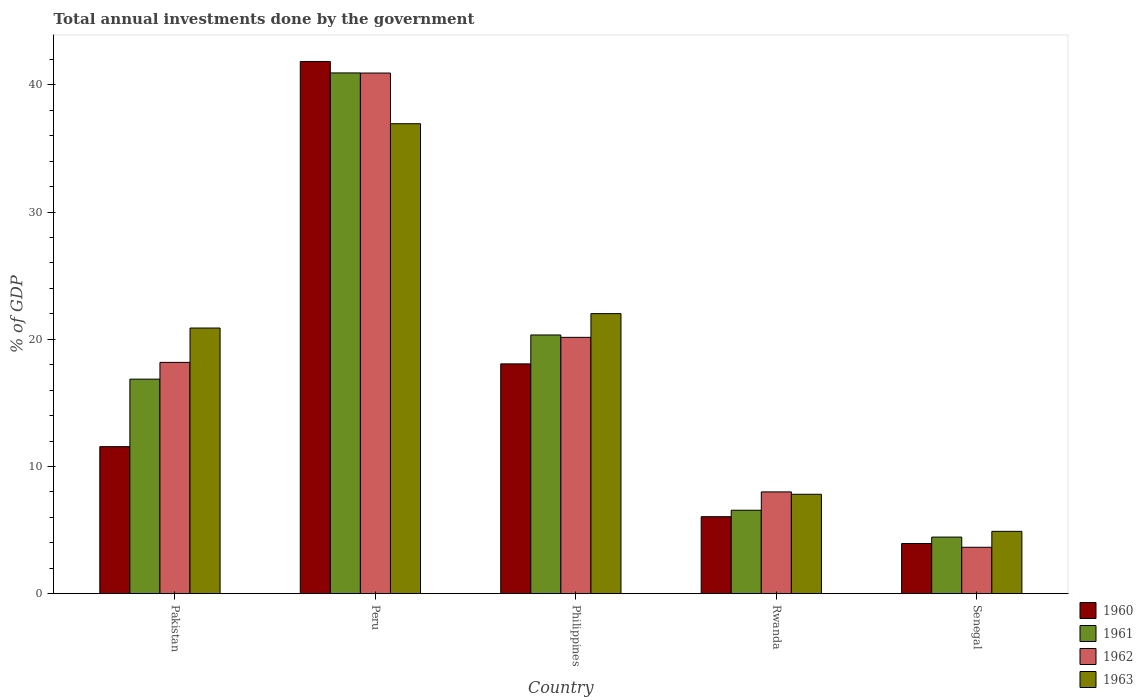How many different coloured bars are there?
Make the answer very short. 4. How many groups of bars are there?
Your response must be concise. 5. Are the number of bars per tick equal to the number of legend labels?
Offer a terse response. Yes. How many bars are there on the 1st tick from the left?
Keep it short and to the point. 4. What is the label of the 1st group of bars from the left?
Your answer should be compact. Pakistan. What is the total annual investments done by the government in 1961 in Senegal?
Make the answer very short. 4.45. Across all countries, what is the maximum total annual investments done by the government in 1960?
Your response must be concise. 41.84. Across all countries, what is the minimum total annual investments done by the government in 1962?
Ensure brevity in your answer.  3.65. In which country was the total annual investments done by the government in 1960 minimum?
Keep it short and to the point. Senegal. What is the total total annual investments done by the government in 1962 in the graph?
Offer a terse response. 90.91. What is the difference between the total annual investments done by the government in 1962 in Peru and that in Philippines?
Ensure brevity in your answer.  20.78. What is the difference between the total annual investments done by the government in 1960 in Philippines and the total annual investments done by the government in 1962 in Rwanda?
Offer a terse response. 10.06. What is the average total annual investments done by the government in 1961 per country?
Make the answer very short. 17.83. What is the difference between the total annual investments done by the government of/in 1961 and total annual investments done by the government of/in 1960 in Philippines?
Give a very brief answer. 2.27. In how many countries, is the total annual investments done by the government in 1963 greater than 40 %?
Provide a short and direct response. 0. What is the ratio of the total annual investments done by the government in 1960 in Peru to that in Rwanda?
Provide a succinct answer. 6.91. What is the difference between the highest and the second highest total annual investments done by the government in 1960?
Keep it short and to the point. 23.77. What is the difference between the highest and the lowest total annual investments done by the government in 1963?
Ensure brevity in your answer.  32.04. What does the 4th bar from the right in Rwanda represents?
Your response must be concise. 1960. How many bars are there?
Your response must be concise. 20. What is the difference between two consecutive major ticks on the Y-axis?
Provide a succinct answer. 10. Are the values on the major ticks of Y-axis written in scientific E-notation?
Your answer should be very brief. No. Does the graph contain grids?
Provide a succinct answer. No. What is the title of the graph?
Offer a terse response. Total annual investments done by the government. What is the label or title of the X-axis?
Give a very brief answer. Country. What is the label or title of the Y-axis?
Your response must be concise. % of GDP. What is the % of GDP of 1960 in Pakistan?
Give a very brief answer. 11.56. What is the % of GDP in 1961 in Pakistan?
Ensure brevity in your answer.  16.86. What is the % of GDP in 1962 in Pakistan?
Give a very brief answer. 18.18. What is the % of GDP of 1963 in Pakistan?
Provide a succinct answer. 20.88. What is the % of GDP of 1960 in Peru?
Give a very brief answer. 41.84. What is the % of GDP of 1961 in Peru?
Provide a succinct answer. 40.94. What is the % of GDP in 1962 in Peru?
Provide a succinct answer. 40.93. What is the % of GDP of 1963 in Peru?
Ensure brevity in your answer.  36.94. What is the % of GDP of 1960 in Philippines?
Ensure brevity in your answer.  18.06. What is the % of GDP of 1961 in Philippines?
Give a very brief answer. 20.34. What is the % of GDP of 1962 in Philippines?
Ensure brevity in your answer.  20.15. What is the % of GDP of 1963 in Philippines?
Give a very brief answer. 22.02. What is the % of GDP in 1960 in Rwanda?
Your response must be concise. 6.05. What is the % of GDP of 1961 in Rwanda?
Provide a short and direct response. 6.56. What is the % of GDP of 1962 in Rwanda?
Give a very brief answer. 8. What is the % of GDP of 1963 in Rwanda?
Give a very brief answer. 7.81. What is the % of GDP in 1960 in Senegal?
Your answer should be compact. 3.94. What is the % of GDP of 1961 in Senegal?
Offer a very short reply. 4.45. What is the % of GDP of 1962 in Senegal?
Your answer should be compact. 3.65. What is the % of GDP of 1963 in Senegal?
Your answer should be compact. 4.9. Across all countries, what is the maximum % of GDP of 1960?
Keep it short and to the point. 41.84. Across all countries, what is the maximum % of GDP in 1961?
Your response must be concise. 40.94. Across all countries, what is the maximum % of GDP of 1962?
Give a very brief answer. 40.93. Across all countries, what is the maximum % of GDP in 1963?
Keep it short and to the point. 36.94. Across all countries, what is the minimum % of GDP in 1960?
Ensure brevity in your answer.  3.94. Across all countries, what is the minimum % of GDP of 1961?
Provide a succinct answer. 4.45. Across all countries, what is the minimum % of GDP of 1962?
Your answer should be compact. 3.65. Across all countries, what is the minimum % of GDP of 1963?
Your answer should be very brief. 4.9. What is the total % of GDP of 1960 in the graph?
Keep it short and to the point. 81.45. What is the total % of GDP in 1961 in the graph?
Provide a short and direct response. 89.14. What is the total % of GDP in 1962 in the graph?
Provide a succinct answer. 90.91. What is the total % of GDP of 1963 in the graph?
Offer a terse response. 92.55. What is the difference between the % of GDP in 1960 in Pakistan and that in Peru?
Provide a succinct answer. -30.28. What is the difference between the % of GDP of 1961 in Pakistan and that in Peru?
Your response must be concise. -24.07. What is the difference between the % of GDP in 1962 in Pakistan and that in Peru?
Your answer should be compact. -22.75. What is the difference between the % of GDP in 1963 in Pakistan and that in Peru?
Your answer should be very brief. -16.06. What is the difference between the % of GDP in 1960 in Pakistan and that in Philippines?
Make the answer very short. -6.51. What is the difference between the % of GDP in 1961 in Pakistan and that in Philippines?
Give a very brief answer. -3.47. What is the difference between the % of GDP in 1962 in Pakistan and that in Philippines?
Ensure brevity in your answer.  -1.97. What is the difference between the % of GDP in 1963 in Pakistan and that in Philippines?
Provide a short and direct response. -1.13. What is the difference between the % of GDP of 1960 in Pakistan and that in Rwanda?
Provide a succinct answer. 5.51. What is the difference between the % of GDP in 1961 in Pakistan and that in Rwanda?
Provide a short and direct response. 10.31. What is the difference between the % of GDP in 1962 in Pakistan and that in Rwanda?
Your response must be concise. 10.18. What is the difference between the % of GDP of 1963 in Pakistan and that in Rwanda?
Make the answer very short. 13.07. What is the difference between the % of GDP in 1960 in Pakistan and that in Senegal?
Provide a short and direct response. 7.62. What is the difference between the % of GDP in 1961 in Pakistan and that in Senegal?
Make the answer very short. 12.42. What is the difference between the % of GDP in 1962 in Pakistan and that in Senegal?
Your answer should be very brief. 14.53. What is the difference between the % of GDP of 1963 in Pakistan and that in Senegal?
Your answer should be compact. 15.98. What is the difference between the % of GDP of 1960 in Peru and that in Philippines?
Offer a very short reply. 23.77. What is the difference between the % of GDP in 1961 in Peru and that in Philippines?
Make the answer very short. 20.6. What is the difference between the % of GDP of 1962 in Peru and that in Philippines?
Ensure brevity in your answer.  20.78. What is the difference between the % of GDP in 1963 in Peru and that in Philippines?
Offer a terse response. 14.93. What is the difference between the % of GDP in 1960 in Peru and that in Rwanda?
Make the answer very short. 35.79. What is the difference between the % of GDP of 1961 in Peru and that in Rwanda?
Provide a short and direct response. 34.38. What is the difference between the % of GDP of 1962 in Peru and that in Rwanda?
Provide a succinct answer. 32.93. What is the difference between the % of GDP of 1963 in Peru and that in Rwanda?
Provide a short and direct response. 29.13. What is the difference between the % of GDP in 1960 in Peru and that in Senegal?
Keep it short and to the point. 37.9. What is the difference between the % of GDP of 1961 in Peru and that in Senegal?
Provide a succinct answer. 36.49. What is the difference between the % of GDP in 1962 in Peru and that in Senegal?
Provide a succinct answer. 37.28. What is the difference between the % of GDP of 1963 in Peru and that in Senegal?
Make the answer very short. 32.04. What is the difference between the % of GDP of 1960 in Philippines and that in Rwanda?
Offer a very short reply. 12.01. What is the difference between the % of GDP in 1961 in Philippines and that in Rwanda?
Keep it short and to the point. 13.78. What is the difference between the % of GDP of 1962 in Philippines and that in Rwanda?
Provide a short and direct response. 12.15. What is the difference between the % of GDP in 1963 in Philippines and that in Rwanda?
Your answer should be very brief. 14.2. What is the difference between the % of GDP in 1960 in Philippines and that in Senegal?
Offer a terse response. 14.12. What is the difference between the % of GDP in 1961 in Philippines and that in Senegal?
Your answer should be very brief. 15.89. What is the difference between the % of GDP of 1962 in Philippines and that in Senegal?
Keep it short and to the point. 16.5. What is the difference between the % of GDP of 1963 in Philippines and that in Senegal?
Your answer should be compact. 17.12. What is the difference between the % of GDP of 1960 in Rwanda and that in Senegal?
Make the answer very short. 2.11. What is the difference between the % of GDP in 1961 in Rwanda and that in Senegal?
Provide a short and direct response. 2.11. What is the difference between the % of GDP of 1962 in Rwanda and that in Senegal?
Make the answer very short. 4.35. What is the difference between the % of GDP of 1963 in Rwanda and that in Senegal?
Provide a short and direct response. 2.91. What is the difference between the % of GDP in 1960 in Pakistan and the % of GDP in 1961 in Peru?
Provide a succinct answer. -29.38. What is the difference between the % of GDP in 1960 in Pakistan and the % of GDP in 1962 in Peru?
Ensure brevity in your answer.  -29.37. What is the difference between the % of GDP of 1960 in Pakistan and the % of GDP of 1963 in Peru?
Offer a terse response. -25.39. What is the difference between the % of GDP of 1961 in Pakistan and the % of GDP of 1962 in Peru?
Give a very brief answer. -24.06. What is the difference between the % of GDP of 1961 in Pakistan and the % of GDP of 1963 in Peru?
Give a very brief answer. -20.08. What is the difference between the % of GDP in 1962 in Pakistan and the % of GDP in 1963 in Peru?
Ensure brevity in your answer.  -18.76. What is the difference between the % of GDP of 1960 in Pakistan and the % of GDP of 1961 in Philippines?
Provide a succinct answer. -8.78. What is the difference between the % of GDP in 1960 in Pakistan and the % of GDP in 1962 in Philippines?
Your response must be concise. -8.59. What is the difference between the % of GDP of 1960 in Pakistan and the % of GDP of 1963 in Philippines?
Your answer should be compact. -10.46. What is the difference between the % of GDP in 1961 in Pakistan and the % of GDP in 1962 in Philippines?
Make the answer very short. -3.29. What is the difference between the % of GDP in 1961 in Pakistan and the % of GDP in 1963 in Philippines?
Offer a very short reply. -5.15. What is the difference between the % of GDP of 1962 in Pakistan and the % of GDP of 1963 in Philippines?
Your answer should be very brief. -3.83. What is the difference between the % of GDP in 1960 in Pakistan and the % of GDP in 1961 in Rwanda?
Keep it short and to the point. 5. What is the difference between the % of GDP in 1960 in Pakistan and the % of GDP in 1962 in Rwanda?
Your answer should be compact. 3.56. What is the difference between the % of GDP of 1960 in Pakistan and the % of GDP of 1963 in Rwanda?
Keep it short and to the point. 3.74. What is the difference between the % of GDP in 1961 in Pakistan and the % of GDP in 1962 in Rwanda?
Your answer should be very brief. 8.86. What is the difference between the % of GDP in 1961 in Pakistan and the % of GDP in 1963 in Rwanda?
Your response must be concise. 9.05. What is the difference between the % of GDP in 1962 in Pakistan and the % of GDP in 1963 in Rwanda?
Make the answer very short. 10.37. What is the difference between the % of GDP of 1960 in Pakistan and the % of GDP of 1961 in Senegal?
Make the answer very short. 7.11. What is the difference between the % of GDP of 1960 in Pakistan and the % of GDP of 1962 in Senegal?
Provide a short and direct response. 7.91. What is the difference between the % of GDP in 1960 in Pakistan and the % of GDP in 1963 in Senegal?
Provide a succinct answer. 6.66. What is the difference between the % of GDP in 1961 in Pakistan and the % of GDP in 1962 in Senegal?
Keep it short and to the point. 13.22. What is the difference between the % of GDP of 1961 in Pakistan and the % of GDP of 1963 in Senegal?
Provide a succinct answer. 11.97. What is the difference between the % of GDP in 1962 in Pakistan and the % of GDP in 1963 in Senegal?
Give a very brief answer. 13.28. What is the difference between the % of GDP of 1960 in Peru and the % of GDP of 1961 in Philippines?
Offer a very short reply. 21.5. What is the difference between the % of GDP in 1960 in Peru and the % of GDP in 1962 in Philippines?
Provide a short and direct response. 21.69. What is the difference between the % of GDP of 1960 in Peru and the % of GDP of 1963 in Philippines?
Make the answer very short. 19.82. What is the difference between the % of GDP of 1961 in Peru and the % of GDP of 1962 in Philippines?
Your response must be concise. 20.79. What is the difference between the % of GDP of 1961 in Peru and the % of GDP of 1963 in Philippines?
Provide a short and direct response. 18.92. What is the difference between the % of GDP in 1962 in Peru and the % of GDP in 1963 in Philippines?
Ensure brevity in your answer.  18.91. What is the difference between the % of GDP of 1960 in Peru and the % of GDP of 1961 in Rwanda?
Your response must be concise. 35.28. What is the difference between the % of GDP of 1960 in Peru and the % of GDP of 1962 in Rwanda?
Your response must be concise. 33.84. What is the difference between the % of GDP in 1960 in Peru and the % of GDP in 1963 in Rwanda?
Your response must be concise. 34.02. What is the difference between the % of GDP in 1961 in Peru and the % of GDP in 1962 in Rwanda?
Ensure brevity in your answer.  32.94. What is the difference between the % of GDP in 1961 in Peru and the % of GDP in 1963 in Rwanda?
Offer a terse response. 33.12. What is the difference between the % of GDP of 1962 in Peru and the % of GDP of 1963 in Rwanda?
Offer a very short reply. 33.12. What is the difference between the % of GDP of 1960 in Peru and the % of GDP of 1961 in Senegal?
Provide a short and direct response. 37.39. What is the difference between the % of GDP in 1960 in Peru and the % of GDP in 1962 in Senegal?
Offer a terse response. 38.19. What is the difference between the % of GDP in 1960 in Peru and the % of GDP in 1963 in Senegal?
Your response must be concise. 36.94. What is the difference between the % of GDP of 1961 in Peru and the % of GDP of 1962 in Senegal?
Ensure brevity in your answer.  37.29. What is the difference between the % of GDP in 1961 in Peru and the % of GDP in 1963 in Senegal?
Your response must be concise. 36.04. What is the difference between the % of GDP in 1962 in Peru and the % of GDP in 1963 in Senegal?
Make the answer very short. 36.03. What is the difference between the % of GDP of 1960 in Philippines and the % of GDP of 1961 in Rwanda?
Your answer should be very brief. 11.51. What is the difference between the % of GDP of 1960 in Philippines and the % of GDP of 1962 in Rwanda?
Your answer should be compact. 10.06. What is the difference between the % of GDP in 1960 in Philippines and the % of GDP in 1963 in Rwanda?
Offer a terse response. 10.25. What is the difference between the % of GDP in 1961 in Philippines and the % of GDP in 1962 in Rwanda?
Provide a short and direct response. 12.34. What is the difference between the % of GDP of 1961 in Philippines and the % of GDP of 1963 in Rwanda?
Offer a very short reply. 12.52. What is the difference between the % of GDP in 1962 in Philippines and the % of GDP in 1963 in Rwanda?
Your answer should be very brief. 12.34. What is the difference between the % of GDP of 1960 in Philippines and the % of GDP of 1961 in Senegal?
Provide a short and direct response. 13.62. What is the difference between the % of GDP in 1960 in Philippines and the % of GDP in 1962 in Senegal?
Your answer should be compact. 14.42. What is the difference between the % of GDP in 1960 in Philippines and the % of GDP in 1963 in Senegal?
Provide a short and direct response. 13.17. What is the difference between the % of GDP of 1961 in Philippines and the % of GDP of 1962 in Senegal?
Your response must be concise. 16.69. What is the difference between the % of GDP in 1961 in Philippines and the % of GDP in 1963 in Senegal?
Give a very brief answer. 15.44. What is the difference between the % of GDP of 1962 in Philippines and the % of GDP of 1963 in Senegal?
Provide a succinct answer. 15.25. What is the difference between the % of GDP in 1960 in Rwanda and the % of GDP in 1961 in Senegal?
Provide a short and direct response. 1.6. What is the difference between the % of GDP of 1960 in Rwanda and the % of GDP of 1962 in Senegal?
Your answer should be very brief. 2.4. What is the difference between the % of GDP in 1960 in Rwanda and the % of GDP in 1963 in Senegal?
Provide a short and direct response. 1.15. What is the difference between the % of GDP in 1961 in Rwanda and the % of GDP in 1962 in Senegal?
Your answer should be compact. 2.91. What is the difference between the % of GDP in 1961 in Rwanda and the % of GDP in 1963 in Senegal?
Offer a terse response. 1.66. What is the difference between the % of GDP in 1962 in Rwanda and the % of GDP in 1963 in Senegal?
Provide a succinct answer. 3.1. What is the average % of GDP of 1960 per country?
Provide a short and direct response. 16.29. What is the average % of GDP of 1961 per country?
Your answer should be very brief. 17.83. What is the average % of GDP in 1962 per country?
Your response must be concise. 18.18. What is the average % of GDP in 1963 per country?
Give a very brief answer. 18.51. What is the difference between the % of GDP of 1960 and % of GDP of 1961 in Pakistan?
Your response must be concise. -5.31. What is the difference between the % of GDP of 1960 and % of GDP of 1962 in Pakistan?
Provide a succinct answer. -6.63. What is the difference between the % of GDP of 1960 and % of GDP of 1963 in Pakistan?
Your response must be concise. -9.33. What is the difference between the % of GDP of 1961 and % of GDP of 1962 in Pakistan?
Provide a succinct answer. -1.32. What is the difference between the % of GDP of 1961 and % of GDP of 1963 in Pakistan?
Provide a short and direct response. -4.02. What is the difference between the % of GDP of 1962 and % of GDP of 1963 in Pakistan?
Your response must be concise. -2.7. What is the difference between the % of GDP of 1960 and % of GDP of 1961 in Peru?
Ensure brevity in your answer.  0.9. What is the difference between the % of GDP of 1960 and % of GDP of 1962 in Peru?
Offer a terse response. 0.91. What is the difference between the % of GDP of 1960 and % of GDP of 1963 in Peru?
Make the answer very short. 4.89. What is the difference between the % of GDP in 1961 and % of GDP in 1962 in Peru?
Your answer should be compact. 0.01. What is the difference between the % of GDP in 1961 and % of GDP in 1963 in Peru?
Offer a very short reply. 3.99. What is the difference between the % of GDP in 1962 and % of GDP in 1963 in Peru?
Your response must be concise. 3.99. What is the difference between the % of GDP of 1960 and % of GDP of 1961 in Philippines?
Ensure brevity in your answer.  -2.27. What is the difference between the % of GDP in 1960 and % of GDP in 1962 in Philippines?
Your answer should be very brief. -2.09. What is the difference between the % of GDP of 1960 and % of GDP of 1963 in Philippines?
Ensure brevity in your answer.  -3.95. What is the difference between the % of GDP in 1961 and % of GDP in 1962 in Philippines?
Give a very brief answer. 0.19. What is the difference between the % of GDP in 1961 and % of GDP in 1963 in Philippines?
Ensure brevity in your answer.  -1.68. What is the difference between the % of GDP of 1962 and % of GDP of 1963 in Philippines?
Your answer should be compact. -1.87. What is the difference between the % of GDP in 1960 and % of GDP in 1961 in Rwanda?
Make the answer very short. -0.51. What is the difference between the % of GDP in 1960 and % of GDP in 1962 in Rwanda?
Your answer should be compact. -1.95. What is the difference between the % of GDP of 1960 and % of GDP of 1963 in Rwanda?
Your answer should be very brief. -1.76. What is the difference between the % of GDP in 1961 and % of GDP in 1962 in Rwanda?
Ensure brevity in your answer.  -1.44. What is the difference between the % of GDP in 1961 and % of GDP in 1963 in Rwanda?
Your answer should be compact. -1.26. What is the difference between the % of GDP in 1962 and % of GDP in 1963 in Rwanda?
Your response must be concise. 0.19. What is the difference between the % of GDP of 1960 and % of GDP of 1961 in Senegal?
Your answer should be very brief. -0.51. What is the difference between the % of GDP of 1960 and % of GDP of 1962 in Senegal?
Offer a terse response. 0.29. What is the difference between the % of GDP in 1960 and % of GDP in 1963 in Senegal?
Make the answer very short. -0.96. What is the difference between the % of GDP of 1961 and % of GDP of 1962 in Senegal?
Your answer should be very brief. 0.8. What is the difference between the % of GDP in 1961 and % of GDP in 1963 in Senegal?
Keep it short and to the point. -0.45. What is the difference between the % of GDP in 1962 and % of GDP in 1963 in Senegal?
Your answer should be very brief. -1.25. What is the ratio of the % of GDP in 1960 in Pakistan to that in Peru?
Ensure brevity in your answer.  0.28. What is the ratio of the % of GDP in 1961 in Pakistan to that in Peru?
Offer a very short reply. 0.41. What is the ratio of the % of GDP in 1962 in Pakistan to that in Peru?
Offer a very short reply. 0.44. What is the ratio of the % of GDP of 1963 in Pakistan to that in Peru?
Keep it short and to the point. 0.57. What is the ratio of the % of GDP in 1960 in Pakistan to that in Philippines?
Your response must be concise. 0.64. What is the ratio of the % of GDP of 1961 in Pakistan to that in Philippines?
Provide a succinct answer. 0.83. What is the ratio of the % of GDP of 1962 in Pakistan to that in Philippines?
Give a very brief answer. 0.9. What is the ratio of the % of GDP of 1963 in Pakistan to that in Philippines?
Ensure brevity in your answer.  0.95. What is the ratio of the % of GDP in 1960 in Pakistan to that in Rwanda?
Your response must be concise. 1.91. What is the ratio of the % of GDP of 1961 in Pakistan to that in Rwanda?
Your answer should be very brief. 2.57. What is the ratio of the % of GDP in 1962 in Pakistan to that in Rwanda?
Offer a very short reply. 2.27. What is the ratio of the % of GDP in 1963 in Pakistan to that in Rwanda?
Your answer should be very brief. 2.67. What is the ratio of the % of GDP in 1960 in Pakistan to that in Senegal?
Your response must be concise. 2.93. What is the ratio of the % of GDP of 1961 in Pakistan to that in Senegal?
Ensure brevity in your answer.  3.79. What is the ratio of the % of GDP of 1962 in Pakistan to that in Senegal?
Give a very brief answer. 4.99. What is the ratio of the % of GDP of 1963 in Pakistan to that in Senegal?
Your response must be concise. 4.26. What is the ratio of the % of GDP in 1960 in Peru to that in Philippines?
Offer a terse response. 2.32. What is the ratio of the % of GDP of 1961 in Peru to that in Philippines?
Ensure brevity in your answer.  2.01. What is the ratio of the % of GDP of 1962 in Peru to that in Philippines?
Ensure brevity in your answer.  2.03. What is the ratio of the % of GDP in 1963 in Peru to that in Philippines?
Offer a very short reply. 1.68. What is the ratio of the % of GDP of 1960 in Peru to that in Rwanda?
Give a very brief answer. 6.91. What is the ratio of the % of GDP of 1961 in Peru to that in Rwanda?
Your response must be concise. 6.24. What is the ratio of the % of GDP of 1962 in Peru to that in Rwanda?
Ensure brevity in your answer.  5.12. What is the ratio of the % of GDP of 1963 in Peru to that in Rwanda?
Your answer should be compact. 4.73. What is the ratio of the % of GDP in 1960 in Peru to that in Senegal?
Offer a very short reply. 10.62. What is the ratio of the % of GDP in 1961 in Peru to that in Senegal?
Give a very brief answer. 9.2. What is the ratio of the % of GDP in 1962 in Peru to that in Senegal?
Offer a very short reply. 11.22. What is the ratio of the % of GDP in 1963 in Peru to that in Senegal?
Make the answer very short. 7.54. What is the ratio of the % of GDP of 1960 in Philippines to that in Rwanda?
Make the answer very short. 2.99. What is the ratio of the % of GDP of 1961 in Philippines to that in Rwanda?
Offer a very short reply. 3.1. What is the ratio of the % of GDP in 1962 in Philippines to that in Rwanda?
Make the answer very short. 2.52. What is the ratio of the % of GDP in 1963 in Philippines to that in Rwanda?
Offer a very short reply. 2.82. What is the ratio of the % of GDP of 1960 in Philippines to that in Senegal?
Your answer should be very brief. 4.58. What is the ratio of the % of GDP of 1961 in Philippines to that in Senegal?
Keep it short and to the point. 4.57. What is the ratio of the % of GDP in 1962 in Philippines to that in Senegal?
Offer a very short reply. 5.53. What is the ratio of the % of GDP of 1963 in Philippines to that in Senegal?
Offer a very short reply. 4.49. What is the ratio of the % of GDP of 1960 in Rwanda to that in Senegal?
Provide a short and direct response. 1.54. What is the ratio of the % of GDP in 1961 in Rwanda to that in Senegal?
Keep it short and to the point. 1.47. What is the ratio of the % of GDP in 1962 in Rwanda to that in Senegal?
Your answer should be compact. 2.19. What is the ratio of the % of GDP of 1963 in Rwanda to that in Senegal?
Provide a short and direct response. 1.59. What is the difference between the highest and the second highest % of GDP in 1960?
Your answer should be very brief. 23.77. What is the difference between the highest and the second highest % of GDP in 1961?
Give a very brief answer. 20.6. What is the difference between the highest and the second highest % of GDP of 1962?
Ensure brevity in your answer.  20.78. What is the difference between the highest and the second highest % of GDP of 1963?
Your answer should be compact. 14.93. What is the difference between the highest and the lowest % of GDP in 1960?
Your response must be concise. 37.9. What is the difference between the highest and the lowest % of GDP of 1961?
Offer a very short reply. 36.49. What is the difference between the highest and the lowest % of GDP of 1962?
Make the answer very short. 37.28. What is the difference between the highest and the lowest % of GDP in 1963?
Make the answer very short. 32.04. 